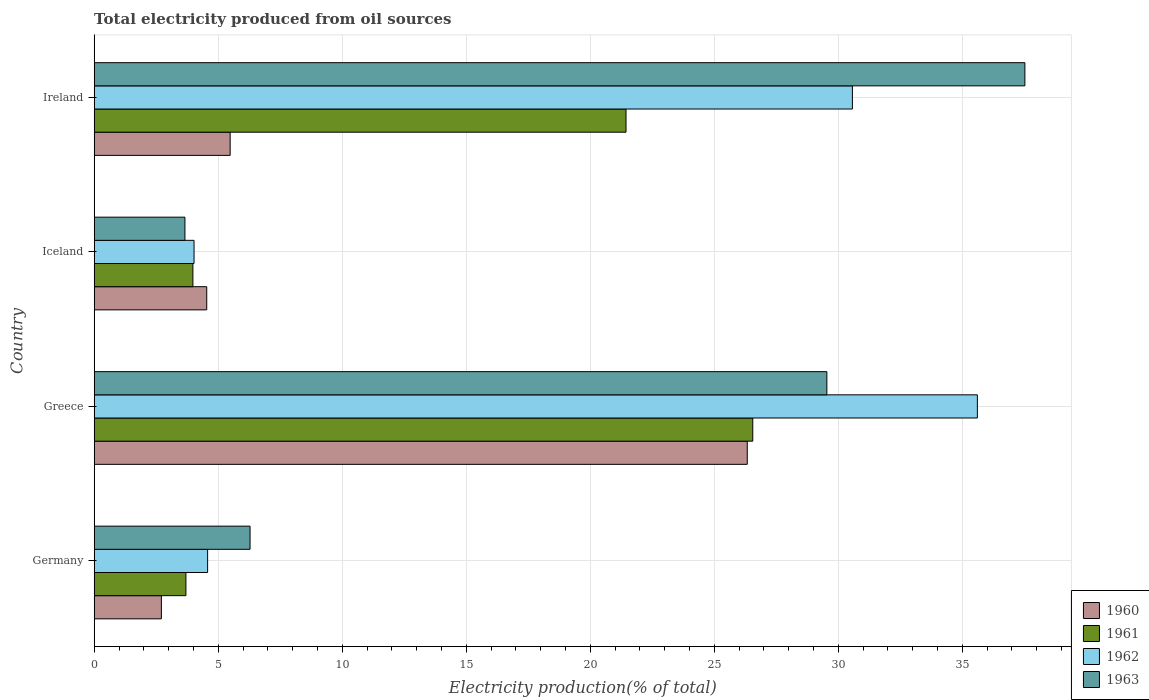How many different coloured bars are there?
Offer a terse response. 4. How many groups of bars are there?
Ensure brevity in your answer.  4. Are the number of bars on each tick of the Y-axis equal?
Make the answer very short. Yes. How many bars are there on the 2nd tick from the top?
Make the answer very short. 4. What is the label of the 4th group of bars from the top?
Offer a terse response. Germany. In how many cases, is the number of bars for a given country not equal to the number of legend labels?
Make the answer very short. 0. What is the total electricity produced in 1961 in Greece?
Ensure brevity in your answer.  26.55. Across all countries, what is the maximum total electricity produced in 1960?
Your answer should be compact. 26.33. Across all countries, what is the minimum total electricity produced in 1961?
Offer a terse response. 3.7. In which country was the total electricity produced in 1962 minimum?
Provide a succinct answer. Iceland. What is the total total electricity produced in 1960 in the graph?
Offer a terse response. 39.06. What is the difference between the total electricity produced in 1963 in Germany and that in Ireland?
Your response must be concise. -31.24. What is the difference between the total electricity produced in 1960 in Greece and the total electricity produced in 1963 in Germany?
Make the answer very short. 20.05. What is the average total electricity produced in 1962 per country?
Provide a succinct answer. 18.69. What is the difference between the total electricity produced in 1962 and total electricity produced in 1960 in Greece?
Your answer should be compact. 9.28. In how many countries, is the total electricity produced in 1963 greater than 25 %?
Provide a succinct answer. 2. What is the ratio of the total electricity produced in 1961 in Iceland to that in Ireland?
Make the answer very short. 0.19. What is the difference between the highest and the second highest total electricity produced in 1962?
Make the answer very short. 5.04. What is the difference between the highest and the lowest total electricity produced in 1963?
Your answer should be compact. 33.87. In how many countries, is the total electricity produced in 1960 greater than the average total electricity produced in 1960 taken over all countries?
Give a very brief answer. 1. Is the sum of the total electricity produced in 1960 in Germany and Ireland greater than the maximum total electricity produced in 1962 across all countries?
Give a very brief answer. No. What does the 2nd bar from the bottom in Germany represents?
Make the answer very short. 1961. Is it the case that in every country, the sum of the total electricity produced in 1960 and total electricity produced in 1963 is greater than the total electricity produced in 1962?
Make the answer very short. Yes. Are all the bars in the graph horizontal?
Offer a very short reply. Yes. How many countries are there in the graph?
Give a very brief answer. 4. What is the difference between two consecutive major ticks on the X-axis?
Provide a short and direct response. 5. Does the graph contain grids?
Your response must be concise. Yes. What is the title of the graph?
Provide a short and direct response. Total electricity produced from oil sources. What is the label or title of the Y-axis?
Give a very brief answer. Country. What is the Electricity production(% of total) of 1960 in Germany?
Offer a very short reply. 2.71. What is the Electricity production(% of total) in 1961 in Germany?
Provide a succinct answer. 3.7. What is the Electricity production(% of total) of 1962 in Germany?
Offer a terse response. 4.57. What is the Electricity production(% of total) in 1963 in Germany?
Your answer should be very brief. 6.28. What is the Electricity production(% of total) in 1960 in Greece?
Offer a very short reply. 26.33. What is the Electricity production(% of total) in 1961 in Greece?
Give a very brief answer. 26.55. What is the Electricity production(% of total) in 1962 in Greece?
Provide a short and direct response. 35.61. What is the Electricity production(% of total) of 1963 in Greece?
Ensure brevity in your answer.  29.54. What is the Electricity production(% of total) of 1960 in Iceland?
Provide a succinct answer. 4.54. What is the Electricity production(% of total) of 1961 in Iceland?
Provide a short and direct response. 3.98. What is the Electricity production(% of total) of 1962 in Iceland?
Offer a terse response. 4.03. What is the Electricity production(% of total) in 1963 in Iceland?
Make the answer very short. 3.66. What is the Electricity production(% of total) in 1960 in Ireland?
Ensure brevity in your answer.  5.48. What is the Electricity production(% of total) of 1961 in Ireland?
Give a very brief answer. 21.44. What is the Electricity production(% of total) in 1962 in Ireland?
Offer a terse response. 30.57. What is the Electricity production(% of total) of 1963 in Ireland?
Your response must be concise. 37.53. Across all countries, what is the maximum Electricity production(% of total) of 1960?
Offer a very short reply. 26.33. Across all countries, what is the maximum Electricity production(% of total) of 1961?
Ensure brevity in your answer.  26.55. Across all countries, what is the maximum Electricity production(% of total) in 1962?
Give a very brief answer. 35.61. Across all countries, what is the maximum Electricity production(% of total) in 1963?
Provide a short and direct response. 37.53. Across all countries, what is the minimum Electricity production(% of total) in 1960?
Your answer should be compact. 2.71. Across all countries, what is the minimum Electricity production(% of total) of 1961?
Ensure brevity in your answer.  3.7. Across all countries, what is the minimum Electricity production(% of total) of 1962?
Provide a succinct answer. 4.03. Across all countries, what is the minimum Electricity production(% of total) in 1963?
Provide a succinct answer. 3.66. What is the total Electricity production(% of total) in 1960 in the graph?
Your answer should be compact. 39.06. What is the total Electricity production(% of total) in 1961 in the graph?
Ensure brevity in your answer.  55.67. What is the total Electricity production(% of total) of 1962 in the graph?
Your answer should be very brief. 74.78. What is the total Electricity production(% of total) in 1963 in the graph?
Ensure brevity in your answer.  77.01. What is the difference between the Electricity production(% of total) of 1960 in Germany and that in Greece?
Offer a terse response. -23.62. What is the difference between the Electricity production(% of total) of 1961 in Germany and that in Greece?
Give a very brief answer. -22.86. What is the difference between the Electricity production(% of total) of 1962 in Germany and that in Greece?
Give a very brief answer. -31.04. What is the difference between the Electricity production(% of total) of 1963 in Germany and that in Greece?
Your answer should be compact. -23.26. What is the difference between the Electricity production(% of total) in 1960 in Germany and that in Iceland?
Provide a short and direct response. -1.83. What is the difference between the Electricity production(% of total) of 1961 in Germany and that in Iceland?
Offer a very short reply. -0.28. What is the difference between the Electricity production(% of total) in 1962 in Germany and that in Iceland?
Keep it short and to the point. 0.55. What is the difference between the Electricity production(% of total) of 1963 in Germany and that in Iceland?
Offer a terse response. 2.63. What is the difference between the Electricity production(% of total) of 1960 in Germany and that in Ireland?
Offer a terse response. -2.77. What is the difference between the Electricity production(% of total) in 1961 in Germany and that in Ireland?
Give a very brief answer. -17.75. What is the difference between the Electricity production(% of total) in 1962 in Germany and that in Ireland?
Offer a very short reply. -26. What is the difference between the Electricity production(% of total) in 1963 in Germany and that in Ireland?
Provide a succinct answer. -31.24. What is the difference between the Electricity production(% of total) in 1960 in Greece and that in Iceland?
Offer a terse response. 21.79. What is the difference between the Electricity production(% of total) in 1961 in Greece and that in Iceland?
Your answer should be very brief. 22.57. What is the difference between the Electricity production(% of total) of 1962 in Greece and that in Iceland?
Your answer should be very brief. 31.58. What is the difference between the Electricity production(% of total) of 1963 in Greece and that in Iceland?
Make the answer very short. 25.88. What is the difference between the Electricity production(% of total) of 1960 in Greece and that in Ireland?
Keep it short and to the point. 20.85. What is the difference between the Electricity production(% of total) in 1961 in Greece and that in Ireland?
Your response must be concise. 5.11. What is the difference between the Electricity production(% of total) of 1962 in Greece and that in Ireland?
Keep it short and to the point. 5.04. What is the difference between the Electricity production(% of total) of 1963 in Greece and that in Ireland?
Give a very brief answer. -7.99. What is the difference between the Electricity production(% of total) in 1960 in Iceland and that in Ireland?
Ensure brevity in your answer.  -0.94. What is the difference between the Electricity production(% of total) of 1961 in Iceland and that in Ireland?
Offer a terse response. -17.46. What is the difference between the Electricity production(% of total) of 1962 in Iceland and that in Ireland?
Provide a short and direct response. -26.55. What is the difference between the Electricity production(% of total) in 1963 in Iceland and that in Ireland?
Keep it short and to the point. -33.87. What is the difference between the Electricity production(% of total) in 1960 in Germany and the Electricity production(% of total) in 1961 in Greece?
Make the answer very short. -23.85. What is the difference between the Electricity production(% of total) in 1960 in Germany and the Electricity production(% of total) in 1962 in Greece?
Give a very brief answer. -32.9. What is the difference between the Electricity production(% of total) in 1960 in Germany and the Electricity production(% of total) in 1963 in Greece?
Offer a very short reply. -26.83. What is the difference between the Electricity production(% of total) of 1961 in Germany and the Electricity production(% of total) of 1962 in Greece?
Your response must be concise. -31.91. What is the difference between the Electricity production(% of total) in 1961 in Germany and the Electricity production(% of total) in 1963 in Greece?
Provide a succinct answer. -25.84. What is the difference between the Electricity production(% of total) in 1962 in Germany and the Electricity production(% of total) in 1963 in Greece?
Your answer should be very brief. -24.97. What is the difference between the Electricity production(% of total) in 1960 in Germany and the Electricity production(% of total) in 1961 in Iceland?
Your response must be concise. -1.27. What is the difference between the Electricity production(% of total) of 1960 in Germany and the Electricity production(% of total) of 1962 in Iceland?
Provide a succinct answer. -1.32. What is the difference between the Electricity production(% of total) in 1960 in Germany and the Electricity production(% of total) in 1963 in Iceland?
Ensure brevity in your answer.  -0.95. What is the difference between the Electricity production(% of total) in 1961 in Germany and the Electricity production(% of total) in 1962 in Iceland?
Provide a succinct answer. -0.33. What is the difference between the Electricity production(% of total) in 1961 in Germany and the Electricity production(% of total) in 1963 in Iceland?
Your answer should be compact. 0.04. What is the difference between the Electricity production(% of total) of 1962 in Germany and the Electricity production(% of total) of 1963 in Iceland?
Offer a terse response. 0.91. What is the difference between the Electricity production(% of total) of 1960 in Germany and the Electricity production(% of total) of 1961 in Ireland?
Keep it short and to the point. -18.73. What is the difference between the Electricity production(% of total) in 1960 in Germany and the Electricity production(% of total) in 1962 in Ireland?
Provide a short and direct response. -27.86. What is the difference between the Electricity production(% of total) in 1960 in Germany and the Electricity production(% of total) in 1963 in Ireland?
Ensure brevity in your answer.  -34.82. What is the difference between the Electricity production(% of total) in 1961 in Germany and the Electricity production(% of total) in 1962 in Ireland?
Provide a succinct answer. -26.87. What is the difference between the Electricity production(% of total) of 1961 in Germany and the Electricity production(% of total) of 1963 in Ireland?
Offer a terse response. -33.83. What is the difference between the Electricity production(% of total) in 1962 in Germany and the Electricity production(% of total) in 1963 in Ireland?
Your answer should be very brief. -32.95. What is the difference between the Electricity production(% of total) of 1960 in Greece and the Electricity production(% of total) of 1961 in Iceland?
Give a very brief answer. 22.35. What is the difference between the Electricity production(% of total) of 1960 in Greece and the Electricity production(% of total) of 1962 in Iceland?
Keep it short and to the point. 22.31. What is the difference between the Electricity production(% of total) in 1960 in Greece and the Electricity production(% of total) in 1963 in Iceland?
Your answer should be compact. 22.67. What is the difference between the Electricity production(% of total) in 1961 in Greece and the Electricity production(% of total) in 1962 in Iceland?
Provide a succinct answer. 22.53. What is the difference between the Electricity production(% of total) of 1961 in Greece and the Electricity production(% of total) of 1963 in Iceland?
Offer a very short reply. 22.9. What is the difference between the Electricity production(% of total) in 1962 in Greece and the Electricity production(% of total) in 1963 in Iceland?
Your answer should be compact. 31.95. What is the difference between the Electricity production(% of total) in 1960 in Greece and the Electricity production(% of total) in 1961 in Ireland?
Make the answer very short. 4.89. What is the difference between the Electricity production(% of total) of 1960 in Greece and the Electricity production(% of total) of 1962 in Ireland?
Your response must be concise. -4.24. What is the difference between the Electricity production(% of total) of 1960 in Greece and the Electricity production(% of total) of 1963 in Ireland?
Your answer should be compact. -11.19. What is the difference between the Electricity production(% of total) in 1961 in Greece and the Electricity production(% of total) in 1962 in Ireland?
Your answer should be very brief. -4.02. What is the difference between the Electricity production(% of total) in 1961 in Greece and the Electricity production(% of total) in 1963 in Ireland?
Offer a terse response. -10.97. What is the difference between the Electricity production(% of total) of 1962 in Greece and the Electricity production(% of total) of 1963 in Ireland?
Your answer should be very brief. -1.92. What is the difference between the Electricity production(% of total) of 1960 in Iceland and the Electricity production(% of total) of 1961 in Ireland?
Keep it short and to the point. -16.91. What is the difference between the Electricity production(% of total) of 1960 in Iceland and the Electricity production(% of total) of 1962 in Ireland?
Your response must be concise. -26.03. What is the difference between the Electricity production(% of total) in 1960 in Iceland and the Electricity production(% of total) in 1963 in Ireland?
Ensure brevity in your answer.  -32.99. What is the difference between the Electricity production(% of total) of 1961 in Iceland and the Electricity production(% of total) of 1962 in Ireland?
Your response must be concise. -26.59. What is the difference between the Electricity production(% of total) of 1961 in Iceland and the Electricity production(% of total) of 1963 in Ireland?
Offer a terse response. -33.55. What is the difference between the Electricity production(% of total) of 1962 in Iceland and the Electricity production(% of total) of 1963 in Ireland?
Your response must be concise. -33.5. What is the average Electricity production(% of total) of 1960 per country?
Offer a terse response. 9.76. What is the average Electricity production(% of total) of 1961 per country?
Your response must be concise. 13.92. What is the average Electricity production(% of total) in 1962 per country?
Offer a terse response. 18.69. What is the average Electricity production(% of total) of 1963 per country?
Provide a short and direct response. 19.25. What is the difference between the Electricity production(% of total) in 1960 and Electricity production(% of total) in 1961 in Germany?
Keep it short and to the point. -0.99. What is the difference between the Electricity production(% of total) in 1960 and Electricity production(% of total) in 1962 in Germany?
Offer a very short reply. -1.86. What is the difference between the Electricity production(% of total) of 1960 and Electricity production(% of total) of 1963 in Germany?
Give a very brief answer. -3.58. What is the difference between the Electricity production(% of total) of 1961 and Electricity production(% of total) of 1962 in Germany?
Give a very brief answer. -0.87. What is the difference between the Electricity production(% of total) of 1961 and Electricity production(% of total) of 1963 in Germany?
Offer a very short reply. -2.59. What is the difference between the Electricity production(% of total) of 1962 and Electricity production(% of total) of 1963 in Germany?
Give a very brief answer. -1.71. What is the difference between the Electricity production(% of total) in 1960 and Electricity production(% of total) in 1961 in Greece?
Offer a terse response. -0.22. What is the difference between the Electricity production(% of total) in 1960 and Electricity production(% of total) in 1962 in Greece?
Provide a succinct answer. -9.28. What is the difference between the Electricity production(% of total) of 1960 and Electricity production(% of total) of 1963 in Greece?
Give a very brief answer. -3.21. What is the difference between the Electricity production(% of total) of 1961 and Electricity production(% of total) of 1962 in Greece?
Give a very brief answer. -9.06. What is the difference between the Electricity production(% of total) in 1961 and Electricity production(% of total) in 1963 in Greece?
Provide a short and direct response. -2.99. What is the difference between the Electricity production(% of total) of 1962 and Electricity production(% of total) of 1963 in Greece?
Provide a succinct answer. 6.07. What is the difference between the Electricity production(% of total) of 1960 and Electricity production(% of total) of 1961 in Iceland?
Offer a very short reply. 0.56. What is the difference between the Electricity production(% of total) of 1960 and Electricity production(% of total) of 1962 in Iceland?
Make the answer very short. 0.51. What is the difference between the Electricity production(% of total) of 1960 and Electricity production(% of total) of 1963 in Iceland?
Offer a very short reply. 0.88. What is the difference between the Electricity production(% of total) of 1961 and Electricity production(% of total) of 1962 in Iceland?
Offer a very short reply. -0.05. What is the difference between the Electricity production(% of total) of 1961 and Electricity production(% of total) of 1963 in Iceland?
Make the answer very short. 0.32. What is the difference between the Electricity production(% of total) in 1962 and Electricity production(% of total) in 1963 in Iceland?
Your answer should be very brief. 0.37. What is the difference between the Electricity production(% of total) in 1960 and Electricity production(% of total) in 1961 in Ireland?
Offer a very short reply. -15.96. What is the difference between the Electricity production(% of total) in 1960 and Electricity production(% of total) in 1962 in Ireland?
Provide a short and direct response. -25.09. What is the difference between the Electricity production(% of total) of 1960 and Electricity production(% of total) of 1963 in Ireland?
Your answer should be compact. -32.04. What is the difference between the Electricity production(% of total) of 1961 and Electricity production(% of total) of 1962 in Ireland?
Your answer should be very brief. -9.13. What is the difference between the Electricity production(% of total) in 1961 and Electricity production(% of total) in 1963 in Ireland?
Your answer should be compact. -16.08. What is the difference between the Electricity production(% of total) of 1962 and Electricity production(% of total) of 1963 in Ireland?
Your response must be concise. -6.95. What is the ratio of the Electricity production(% of total) of 1960 in Germany to that in Greece?
Give a very brief answer. 0.1. What is the ratio of the Electricity production(% of total) of 1961 in Germany to that in Greece?
Ensure brevity in your answer.  0.14. What is the ratio of the Electricity production(% of total) in 1962 in Germany to that in Greece?
Offer a very short reply. 0.13. What is the ratio of the Electricity production(% of total) in 1963 in Germany to that in Greece?
Your answer should be very brief. 0.21. What is the ratio of the Electricity production(% of total) in 1960 in Germany to that in Iceland?
Offer a terse response. 0.6. What is the ratio of the Electricity production(% of total) of 1961 in Germany to that in Iceland?
Offer a terse response. 0.93. What is the ratio of the Electricity production(% of total) in 1962 in Germany to that in Iceland?
Make the answer very short. 1.14. What is the ratio of the Electricity production(% of total) in 1963 in Germany to that in Iceland?
Your answer should be compact. 1.72. What is the ratio of the Electricity production(% of total) of 1960 in Germany to that in Ireland?
Your answer should be very brief. 0.49. What is the ratio of the Electricity production(% of total) of 1961 in Germany to that in Ireland?
Offer a very short reply. 0.17. What is the ratio of the Electricity production(% of total) in 1962 in Germany to that in Ireland?
Offer a terse response. 0.15. What is the ratio of the Electricity production(% of total) in 1963 in Germany to that in Ireland?
Your response must be concise. 0.17. What is the ratio of the Electricity production(% of total) in 1960 in Greece to that in Iceland?
Ensure brevity in your answer.  5.8. What is the ratio of the Electricity production(% of total) of 1961 in Greece to that in Iceland?
Make the answer very short. 6.67. What is the ratio of the Electricity production(% of total) in 1962 in Greece to that in Iceland?
Your response must be concise. 8.85. What is the ratio of the Electricity production(% of total) of 1963 in Greece to that in Iceland?
Give a very brief answer. 8.07. What is the ratio of the Electricity production(% of total) in 1960 in Greece to that in Ireland?
Your answer should be compact. 4.8. What is the ratio of the Electricity production(% of total) of 1961 in Greece to that in Ireland?
Make the answer very short. 1.24. What is the ratio of the Electricity production(% of total) in 1962 in Greece to that in Ireland?
Give a very brief answer. 1.16. What is the ratio of the Electricity production(% of total) of 1963 in Greece to that in Ireland?
Give a very brief answer. 0.79. What is the ratio of the Electricity production(% of total) in 1960 in Iceland to that in Ireland?
Give a very brief answer. 0.83. What is the ratio of the Electricity production(% of total) in 1961 in Iceland to that in Ireland?
Your answer should be very brief. 0.19. What is the ratio of the Electricity production(% of total) in 1962 in Iceland to that in Ireland?
Your answer should be compact. 0.13. What is the ratio of the Electricity production(% of total) in 1963 in Iceland to that in Ireland?
Make the answer very short. 0.1. What is the difference between the highest and the second highest Electricity production(% of total) of 1960?
Your response must be concise. 20.85. What is the difference between the highest and the second highest Electricity production(% of total) in 1961?
Give a very brief answer. 5.11. What is the difference between the highest and the second highest Electricity production(% of total) of 1962?
Ensure brevity in your answer.  5.04. What is the difference between the highest and the second highest Electricity production(% of total) in 1963?
Your answer should be very brief. 7.99. What is the difference between the highest and the lowest Electricity production(% of total) of 1960?
Offer a very short reply. 23.62. What is the difference between the highest and the lowest Electricity production(% of total) of 1961?
Keep it short and to the point. 22.86. What is the difference between the highest and the lowest Electricity production(% of total) of 1962?
Provide a short and direct response. 31.58. What is the difference between the highest and the lowest Electricity production(% of total) of 1963?
Ensure brevity in your answer.  33.87. 